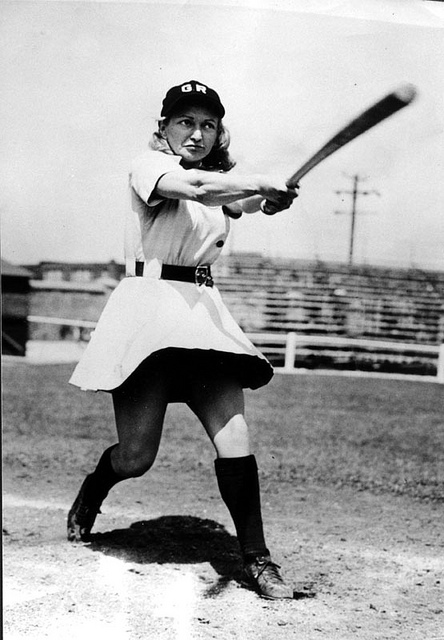<image>What drink logo is on the scoreboard? There is no scoreboard in the image. However, if there were, it could possibly show a 'coke' or 'pepsi' logo. What drink logo is on the scoreboard? It is unknown what drink logo is on the scoreboard. No scoreboard is visible in the image. 